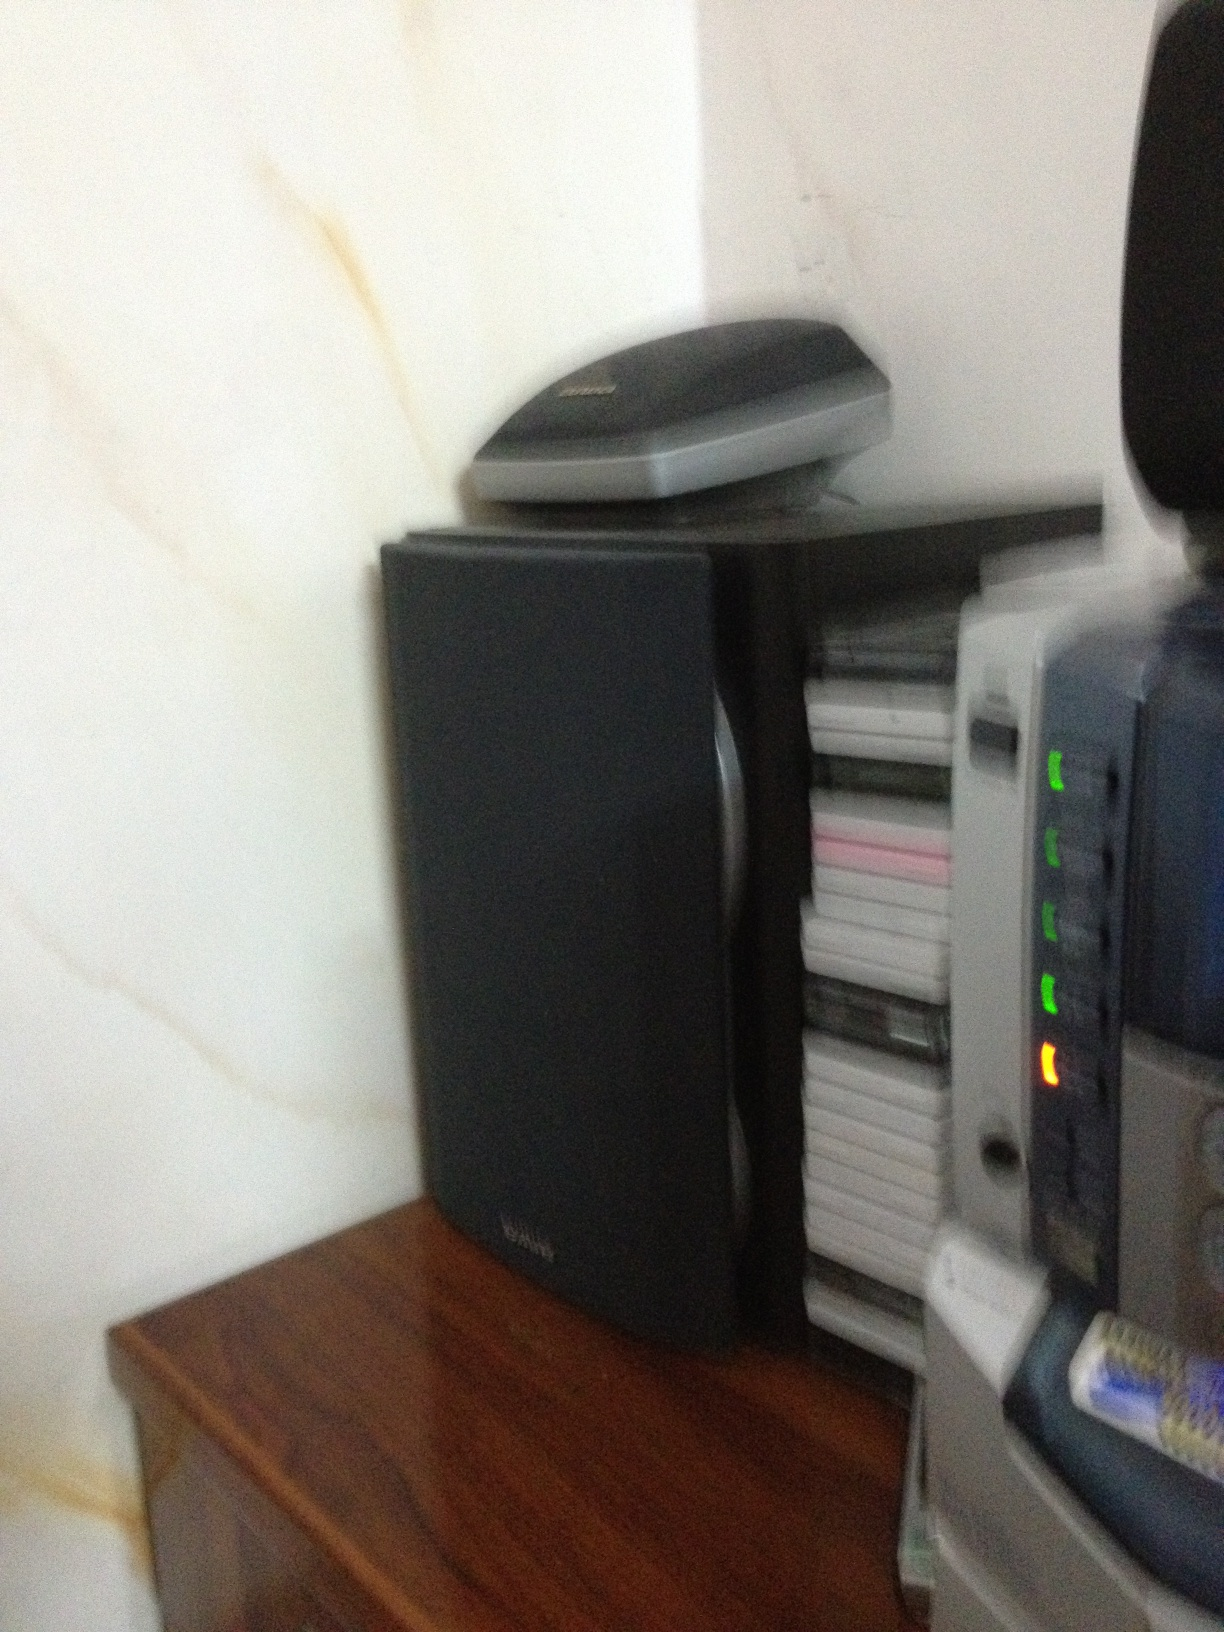Can you describe the setup in this image in detail? Certainly! This image seems to depict a small corner with various electronic equipment. At the forefront, there is a black speaker placed on a wooden surface. To its right, a stack of electronic media such as CDs or DVDs can be seen, organized neatly. Above the speaker, there appears to be a flatbed scanner. On the far right edge, there is an electronic device with various indicator lights, possibly a printer or a stereo system. 